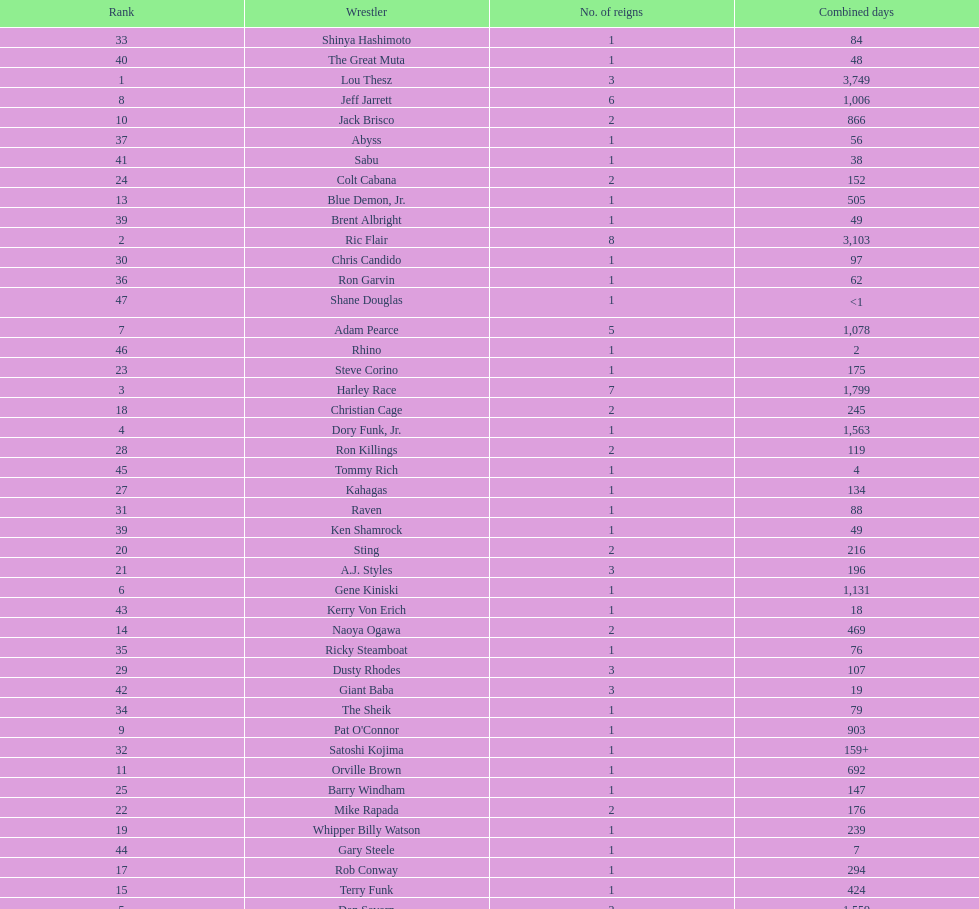Which professional wrestler has had the most number of reigns as nwa world heavyweight champion? Ric Flair. 